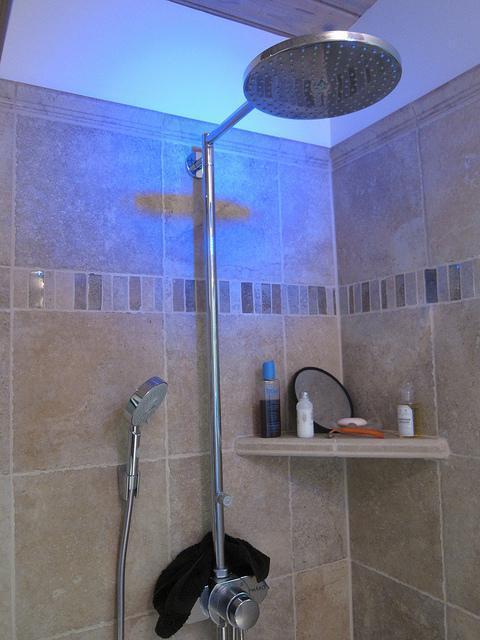How many white cars are there?
Give a very brief answer. 0. 